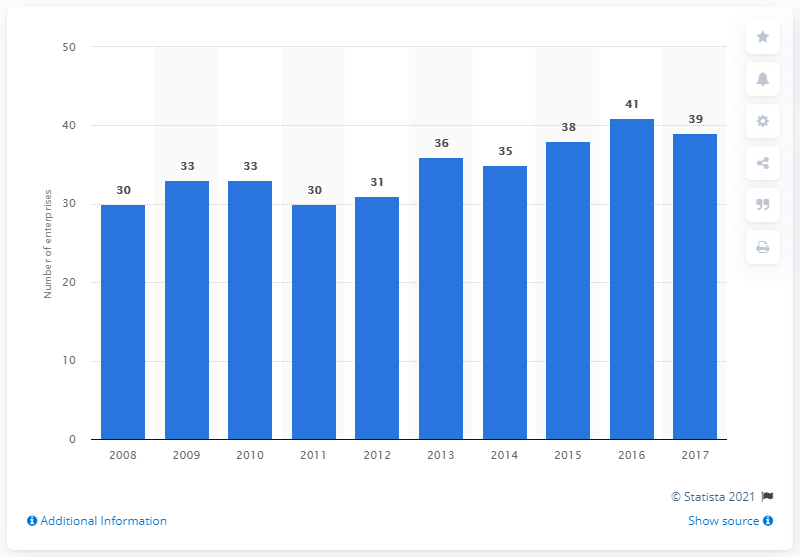Highlight a few significant elements in this photo. In 2017, there were 39 enterprises in the cocoa, chocolate, and sugar confectionery industry in Austria. 